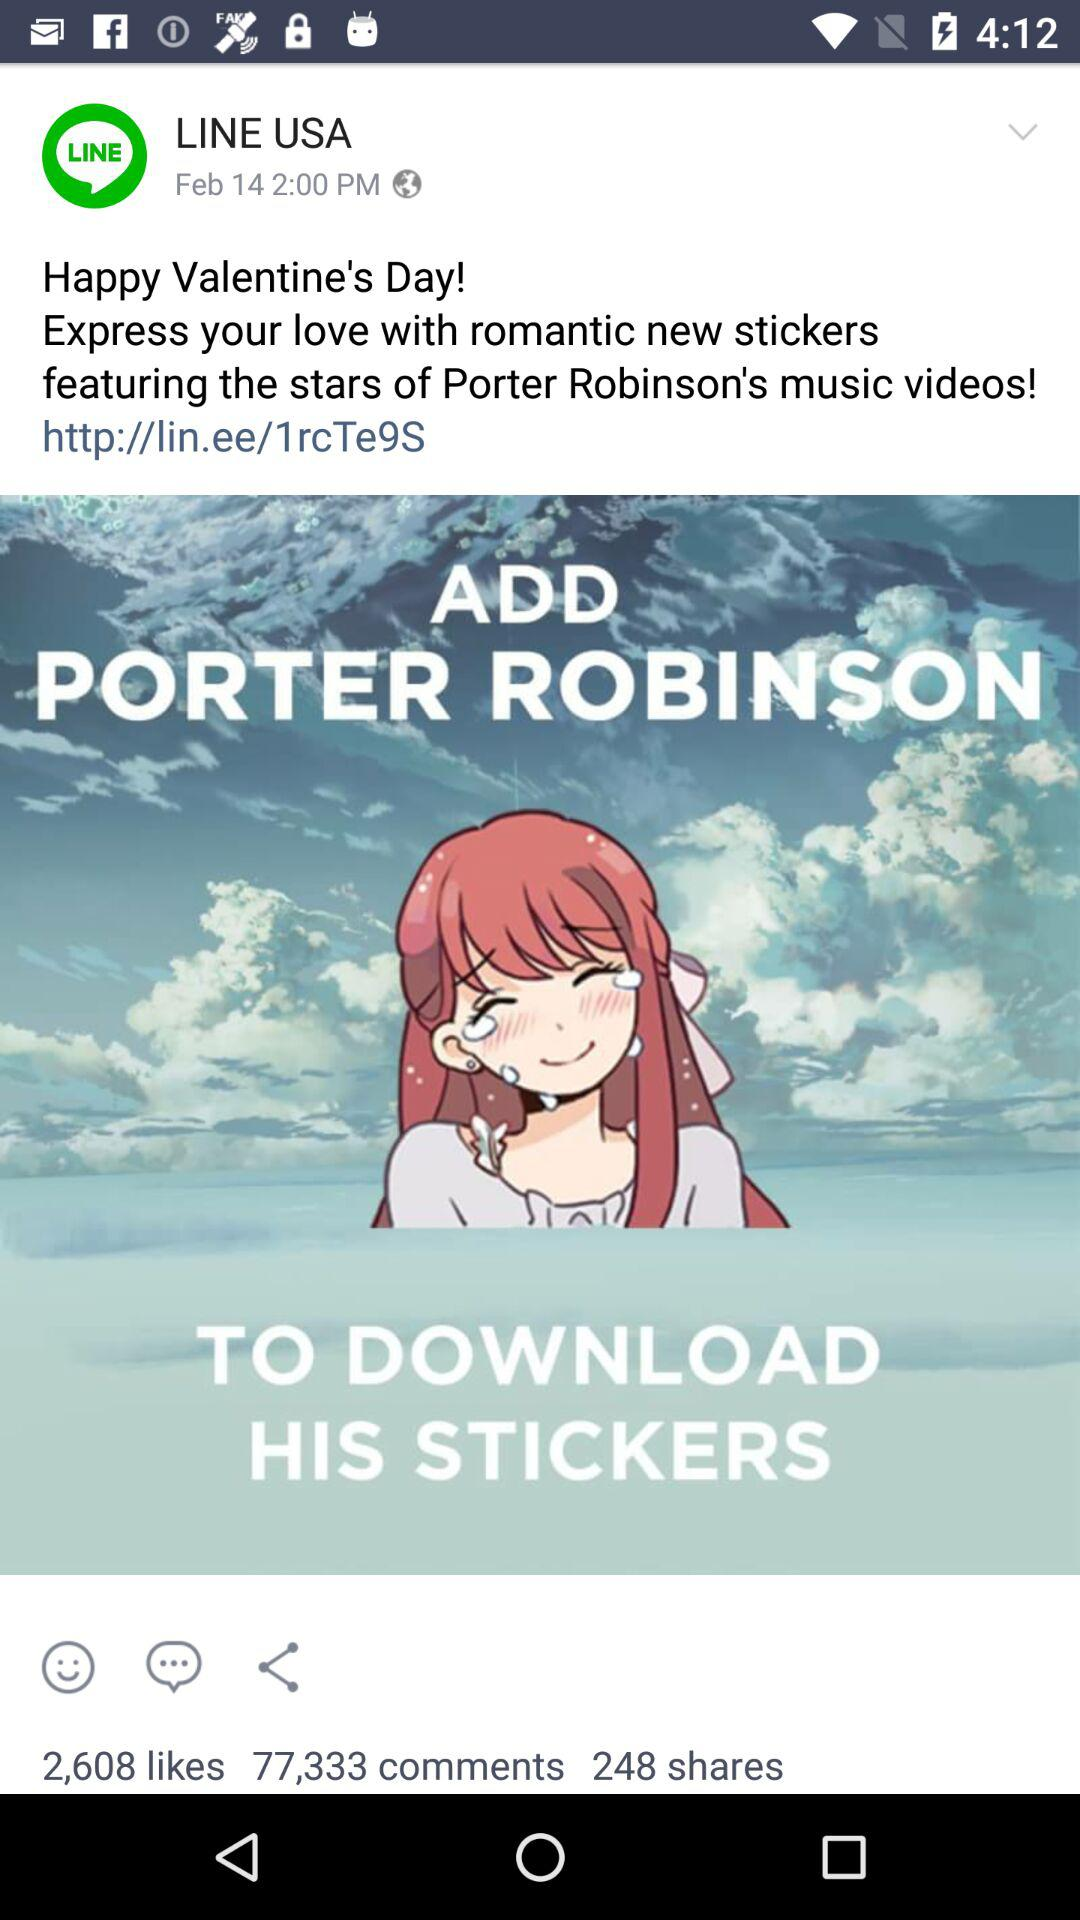How many shares did the sticker post get? The post got 248 shares. 